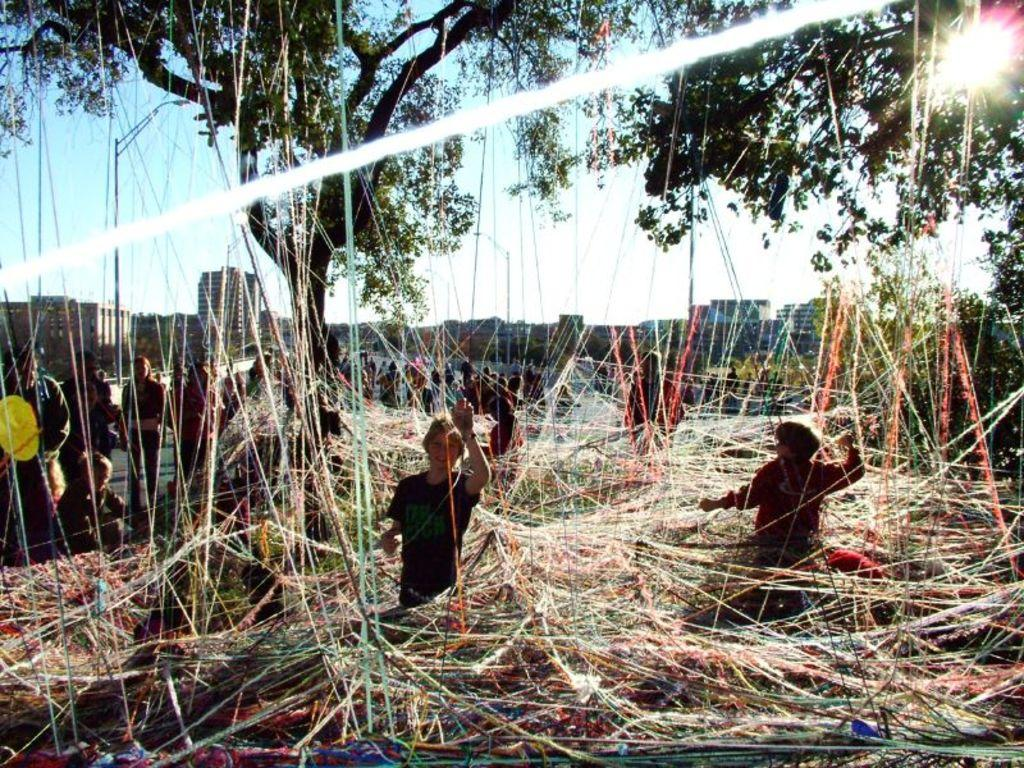What is happening in the image involving people? There are groups of people standing in the image. What can be seen in the image that is related to textiles or fabric? There are threads visible in the image. What type of plant is present in the image? There is a tree with branches and leaves in the image. What can be seen in the distance in the image? There are buildings in the background of the image. What type of truck is parked near the tree in the image? There is no truck present in the image; it only features groups of people, threads, a tree, and buildings in the background. 